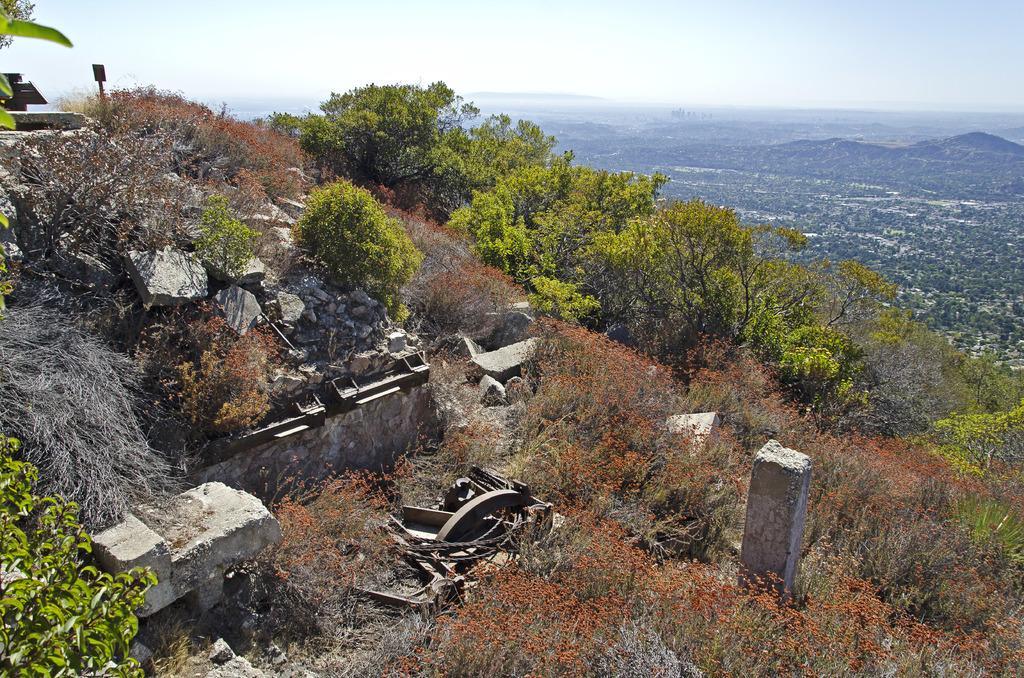Can you describe this image briefly? This is an outside view. Here I can see many rocks, trees and plants on the ground and there are few metal objects. In the background there are few hills. At the top of the image I can see the sky. 